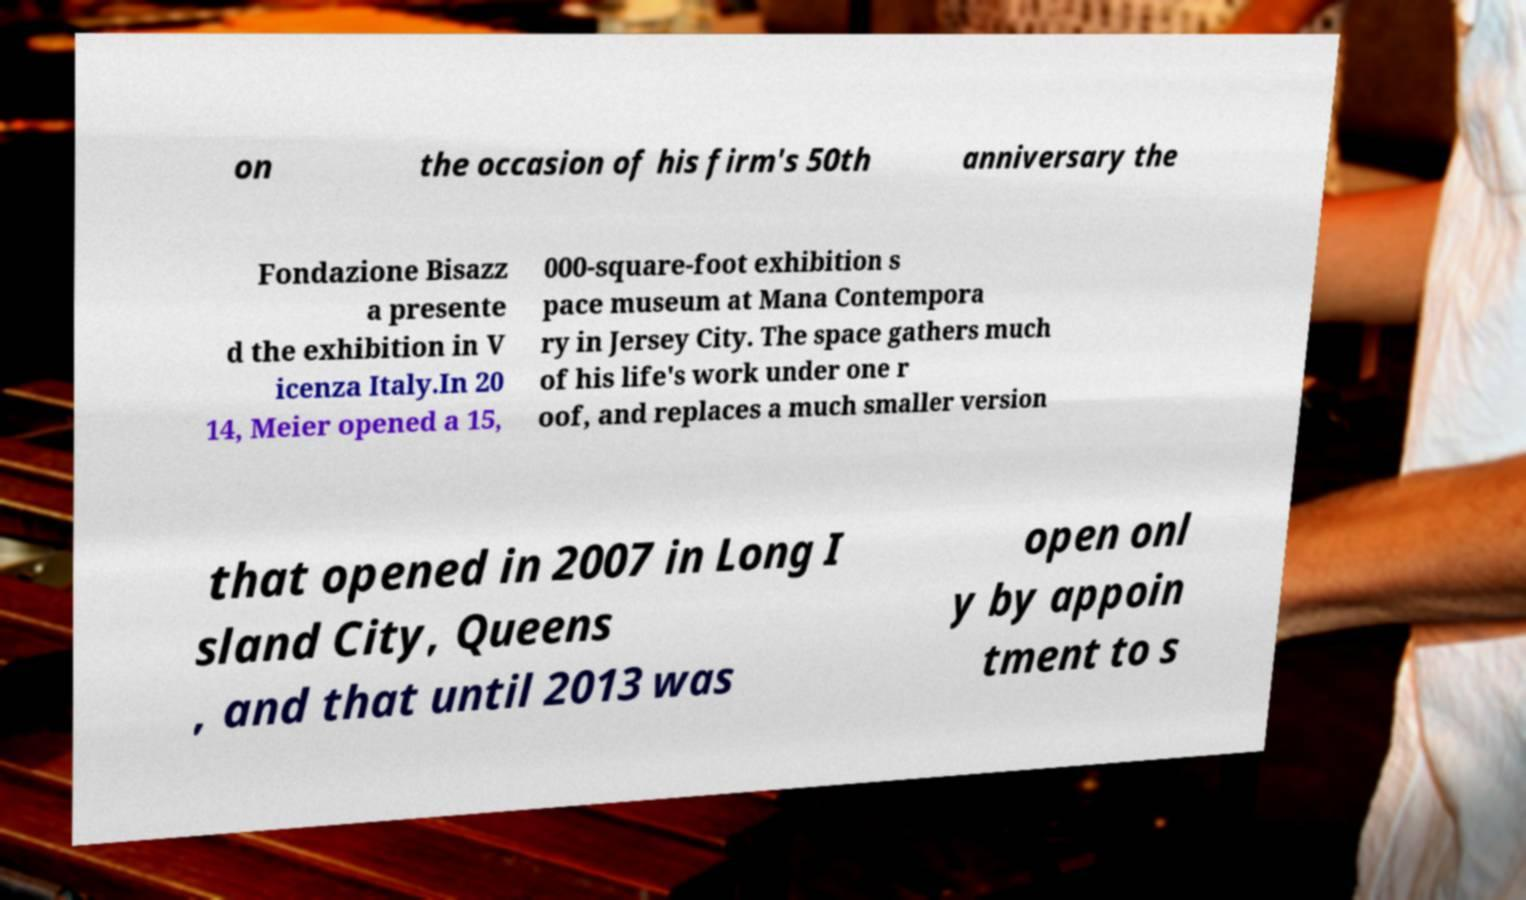Please read and relay the text visible in this image. What does it say? on the occasion of his firm's 50th anniversary the Fondazione Bisazz a presente d the exhibition in V icenza Italy.In 20 14, Meier opened a 15, 000-square-foot exhibition s pace museum at Mana Contempora ry in Jersey City. The space gathers much of his life's work under one r oof, and replaces a much smaller version that opened in 2007 in Long I sland City, Queens , and that until 2013 was open onl y by appoin tment to s 